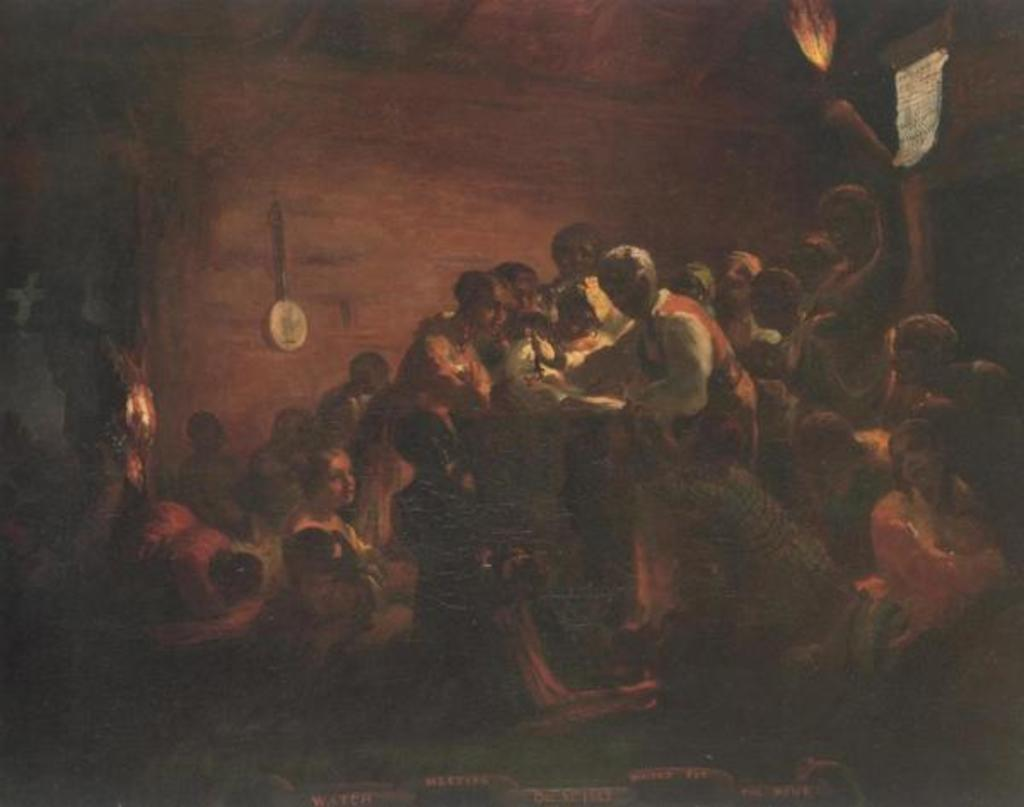What is the main subject of the image? There is a painting in the image. What is shown in the painting? The painting depicts a few people. What type of corn is growing in the image? There is no corn present in the image; it features a painting depicting a few people. What colors are the flowers in the image? There are no flowers present in the image; it features a painting depicting a few people. 